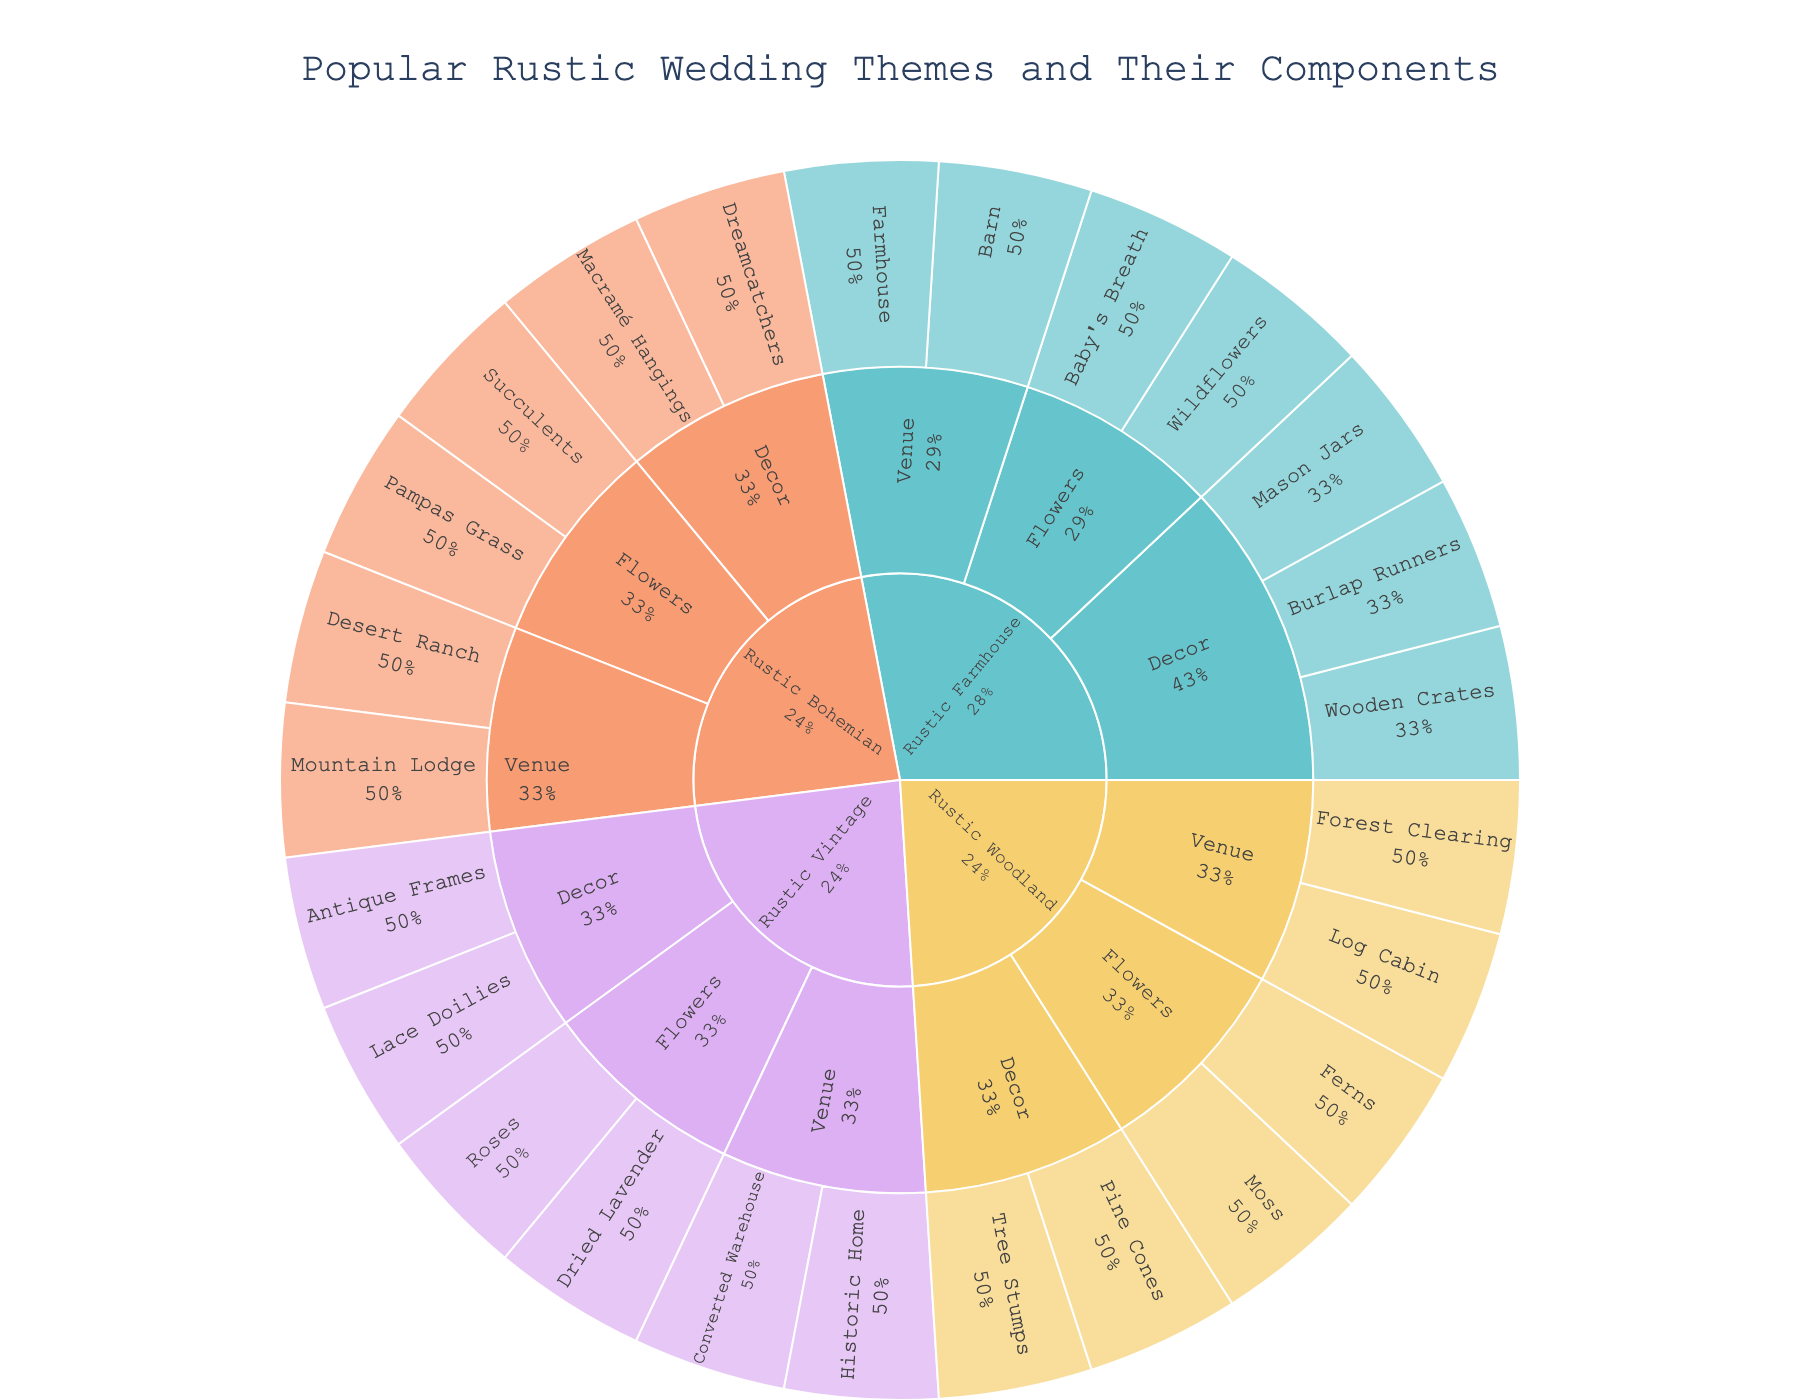what is the title of the plot? The title of the plot is displayed prominently at the top center of the figure. It provides a summary of the data being visualized.
Answer: Popular Rustic Wedding Themes and Their Components How many main themes are there in the plot? To identify the number of main themes, look at the outermost layer of the sunburst plot, where the themes are labeled. Count the distinct labels around the circle.
Answer: 4 Which element is included under the decor category for Rustic Bohemian? Find the "Rustic Bohemian" theme in the plot, then move one level inward to locate the "Decor" category. The elements will be listed radially within this section.
Answer: Dreamcatchers, Macramé Hangings Which theme has more elements in the 'Flowers' category: Rustic Woodland or Rustic Vintage? Look at the 'Flowers' category for each of the two themes. Count the number of elements listed in each category. Rustic Woodland has Ferns and Moss, while Rustic Vintage has Dried Lavender and Roses. Both have the same count.
Answer: Both have 2 elements How many elements belong to 'Venue' in total across all themes? Examine each theme and count the elements listed under the 'Venue' category. Sum these counts to get the total number of 'Venue' elements. Rustic Farmhouse has 2, Rustic Woodland has 2, Rustic Vintage has 2, and Rustic Bohemian has 2. 2 + 2 + 2 + 2 = 8
Answer: 8 Which theme features the element "Wildflowers" under 'Flowers'? Locate "Wildflowers" within the innermost layer of the plot and trace outward through its parent categories until you reach the main theme.
Answer: Rustic Farmhouse In which theme does the category 'Venue' include a 'Forest Clearing'? Find 'Forest Clearing' in the sunburst plot and trace it back through its parent categories until you reach the main theme.
Answer: Rustic Woodland Which theme contains both 'Antique Frames' and 'Lace Doilies' in the 'Decor' category? Look at the 'Decor' category for each theme and check for the presence of both 'Antique Frames' and 'Lace Doilies' within that category.
Answer: Rustic Vintage If you combine all the 'Flowers' elements from 'Rustic Farmhouse' and 'Rustic Bohemian', how many unique elements would you have? List the 'Flowers' elements for both themes. Rustic Farmhouse has Wildflowers and Baby's Breath. Rustic Bohemian has Pampas Grass and Succulents. Combine these and count unique elements.
Answer: 4 Which flower element appears in a theme that also has the venue element 'Barn'? Locate the theme that includes 'Barn' in the 'Venue' category and check the 'Flowers' category for that theme.
Answer: Wildflowers, Baby's Breath 